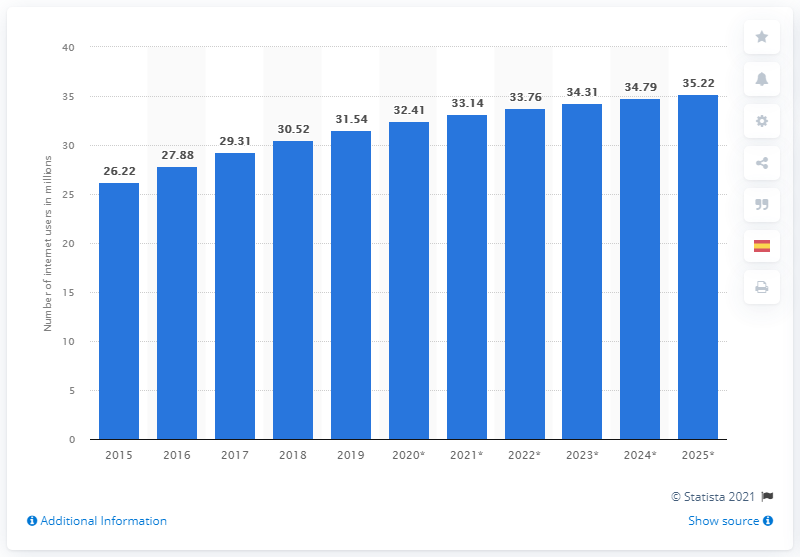Mention a couple of crucial points in this snapshot. By 2025, it is expected that a significant number of people will connect to the web. Specifically, it is projected that 35.22 people will connect to the web by that year. In 2019, there were approximately 31.54 million internet users in Argentina. 